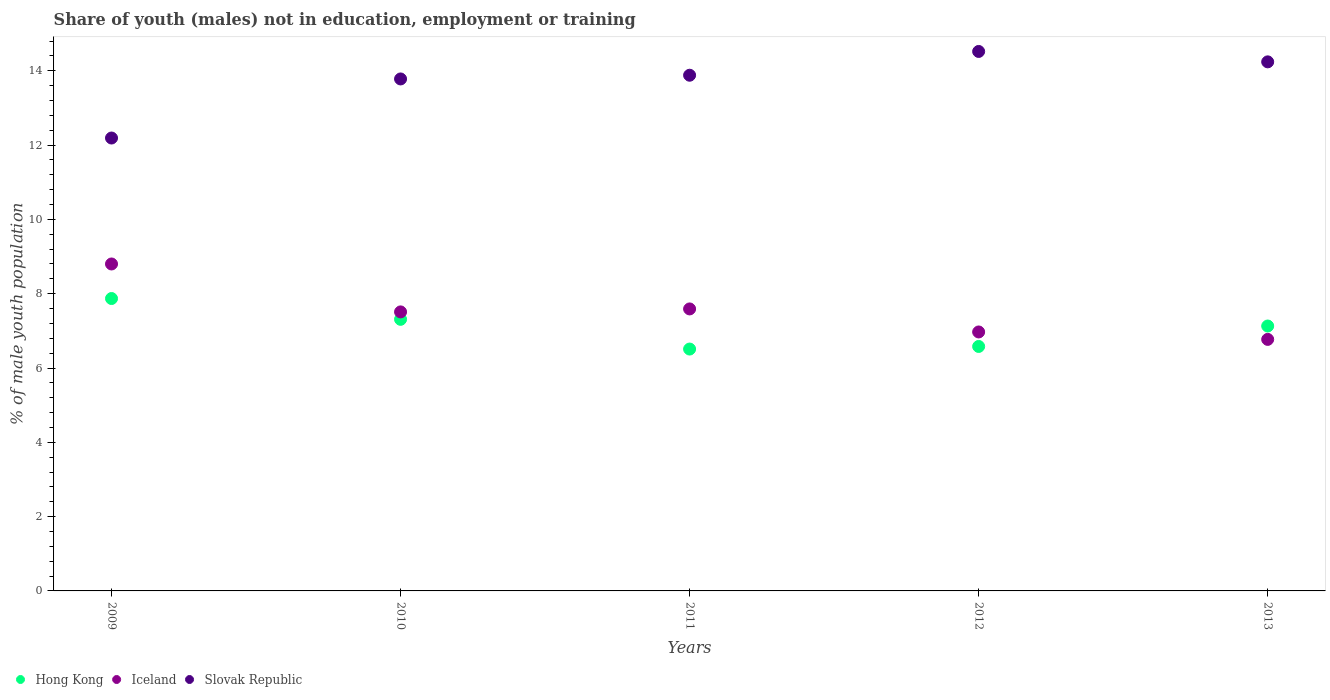How many different coloured dotlines are there?
Give a very brief answer. 3. Is the number of dotlines equal to the number of legend labels?
Ensure brevity in your answer.  Yes. What is the percentage of unemployed males population in in Hong Kong in 2013?
Keep it short and to the point. 7.13. Across all years, what is the maximum percentage of unemployed males population in in Slovak Republic?
Ensure brevity in your answer.  14.52. Across all years, what is the minimum percentage of unemployed males population in in Iceland?
Offer a terse response. 6.77. In which year was the percentage of unemployed males population in in Hong Kong maximum?
Keep it short and to the point. 2009. In which year was the percentage of unemployed males population in in Hong Kong minimum?
Provide a short and direct response. 2011. What is the total percentage of unemployed males population in in Iceland in the graph?
Offer a very short reply. 37.64. What is the difference between the percentage of unemployed males population in in Slovak Republic in 2011 and that in 2012?
Your answer should be compact. -0.64. What is the difference between the percentage of unemployed males population in in Slovak Republic in 2011 and the percentage of unemployed males population in in Iceland in 2013?
Make the answer very short. 7.11. What is the average percentage of unemployed males population in in Slovak Republic per year?
Ensure brevity in your answer.  13.72. In the year 2009, what is the difference between the percentage of unemployed males population in in Hong Kong and percentage of unemployed males population in in Iceland?
Keep it short and to the point. -0.93. In how many years, is the percentage of unemployed males population in in Iceland greater than 14.4 %?
Provide a short and direct response. 0. What is the ratio of the percentage of unemployed males population in in Slovak Republic in 2010 to that in 2011?
Provide a succinct answer. 0.99. Is the difference between the percentage of unemployed males population in in Hong Kong in 2011 and 2013 greater than the difference between the percentage of unemployed males population in in Iceland in 2011 and 2013?
Ensure brevity in your answer.  No. What is the difference between the highest and the second highest percentage of unemployed males population in in Slovak Republic?
Ensure brevity in your answer.  0.28. What is the difference between the highest and the lowest percentage of unemployed males population in in Slovak Republic?
Provide a short and direct response. 2.33. Does the percentage of unemployed males population in in Hong Kong monotonically increase over the years?
Offer a terse response. No. Is the percentage of unemployed males population in in Hong Kong strictly greater than the percentage of unemployed males population in in Iceland over the years?
Give a very brief answer. No. How many years are there in the graph?
Give a very brief answer. 5. What is the difference between two consecutive major ticks on the Y-axis?
Make the answer very short. 2. Are the values on the major ticks of Y-axis written in scientific E-notation?
Keep it short and to the point. No. Does the graph contain any zero values?
Your answer should be very brief. No. Does the graph contain grids?
Make the answer very short. No. Where does the legend appear in the graph?
Offer a very short reply. Bottom left. What is the title of the graph?
Ensure brevity in your answer.  Share of youth (males) not in education, employment or training. Does "Ireland" appear as one of the legend labels in the graph?
Your answer should be compact. No. What is the label or title of the Y-axis?
Provide a short and direct response. % of male youth population. What is the % of male youth population in Hong Kong in 2009?
Offer a very short reply. 7.87. What is the % of male youth population of Iceland in 2009?
Ensure brevity in your answer.  8.8. What is the % of male youth population of Slovak Republic in 2009?
Your answer should be compact. 12.19. What is the % of male youth population of Hong Kong in 2010?
Offer a very short reply. 7.31. What is the % of male youth population in Iceland in 2010?
Offer a terse response. 7.51. What is the % of male youth population of Slovak Republic in 2010?
Provide a short and direct response. 13.78. What is the % of male youth population in Hong Kong in 2011?
Provide a succinct answer. 6.51. What is the % of male youth population in Iceland in 2011?
Give a very brief answer. 7.59. What is the % of male youth population of Slovak Republic in 2011?
Make the answer very short. 13.88. What is the % of male youth population in Hong Kong in 2012?
Offer a terse response. 6.58. What is the % of male youth population of Iceland in 2012?
Your response must be concise. 6.97. What is the % of male youth population of Slovak Republic in 2012?
Your response must be concise. 14.52. What is the % of male youth population of Hong Kong in 2013?
Keep it short and to the point. 7.13. What is the % of male youth population in Iceland in 2013?
Your answer should be very brief. 6.77. What is the % of male youth population in Slovak Republic in 2013?
Your response must be concise. 14.24. Across all years, what is the maximum % of male youth population in Hong Kong?
Provide a succinct answer. 7.87. Across all years, what is the maximum % of male youth population of Iceland?
Provide a short and direct response. 8.8. Across all years, what is the maximum % of male youth population in Slovak Republic?
Make the answer very short. 14.52. Across all years, what is the minimum % of male youth population of Hong Kong?
Make the answer very short. 6.51. Across all years, what is the minimum % of male youth population in Iceland?
Keep it short and to the point. 6.77. Across all years, what is the minimum % of male youth population in Slovak Republic?
Make the answer very short. 12.19. What is the total % of male youth population of Hong Kong in the graph?
Keep it short and to the point. 35.4. What is the total % of male youth population in Iceland in the graph?
Provide a succinct answer. 37.64. What is the total % of male youth population in Slovak Republic in the graph?
Provide a succinct answer. 68.61. What is the difference between the % of male youth population of Hong Kong in 2009 and that in 2010?
Offer a very short reply. 0.56. What is the difference between the % of male youth population in Iceland in 2009 and that in 2010?
Offer a terse response. 1.29. What is the difference between the % of male youth population in Slovak Republic in 2009 and that in 2010?
Provide a succinct answer. -1.59. What is the difference between the % of male youth population of Hong Kong in 2009 and that in 2011?
Keep it short and to the point. 1.36. What is the difference between the % of male youth population in Iceland in 2009 and that in 2011?
Keep it short and to the point. 1.21. What is the difference between the % of male youth population in Slovak Republic in 2009 and that in 2011?
Your answer should be compact. -1.69. What is the difference between the % of male youth population of Hong Kong in 2009 and that in 2012?
Give a very brief answer. 1.29. What is the difference between the % of male youth population of Iceland in 2009 and that in 2012?
Give a very brief answer. 1.83. What is the difference between the % of male youth population of Slovak Republic in 2009 and that in 2012?
Provide a short and direct response. -2.33. What is the difference between the % of male youth population in Hong Kong in 2009 and that in 2013?
Give a very brief answer. 0.74. What is the difference between the % of male youth population of Iceland in 2009 and that in 2013?
Offer a terse response. 2.03. What is the difference between the % of male youth population in Slovak Republic in 2009 and that in 2013?
Offer a terse response. -2.05. What is the difference between the % of male youth population of Iceland in 2010 and that in 2011?
Ensure brevity in your answer.  -0.08. What is the difference between the % of male youth population of Hong Kong in 2010 and that in 2012?
Offer a very short reply. 0.73. What is the difference between the % of male youth population in Iceland in 2010 and that in 2012?
Your answer should be very brief. 0.54. What is the difference between the % of male youth population of Slovak Republic in 2010 and that in 2012?
Provide a short and direct response. -0.74. What is the difference between the % of male youth population in Hong Kong in 2010 and that in 2013?
Keep it short and to the point. 0.18. What is the difference between the % of male youth population in Iceland in 2010 and that in 2013?
Offer a terse response. 0.74. What is the difference between the % of male youth population in Slovak Republic in 2010 and that in 2013?
Make the answer very short. -0.46. What is the difference between the % of male youth population of Hong Kong in 2011 and that in 2012?
Make the answer very short. -0.07. What is the difference between the % of male youth population of Iceland in 2011 and that in 2012?
Give a very brief answer. 0.62. What is the difference between the % of male youth population in Slovak Republic in 2011 and that in 2012?
Offer a terse response. -0.64. What is the difference between the % of male youth population of Hong Kong in 2011 and that in 2013?
Keep it short and to the point. -0.62. What is the difference between the % of male youth population of Iceland in 2011 and that in 2013?
Make the answer very short. 0.82. What is the difference between the % of male youth population in Slovak Republic in 2011 and that in 2013?
Offer a very short reply. -0.36. What is the difference between the % of male youth population in Hong Kong in 2012 and that in 2013?
Your answer should be very brief. -0.55. What is the difference between the % of male youth population in Iceland in 2012 and that in 2013?
Provide a succinct answer. 0.2. What is the difference between the % of male youth population in Slovak Republic in 2012 and that in 2013?
Keep it short and to the point. 0.28. What is the difference between the % of male youth population of Hong Kong in 2009 and the % of male youth population of Iceland in 2010?
Your answer should be very brief. 0.36. What is the difference between the % of male youth population of Hong Kong in 2009 and the % of male youth population of Slovak Republic in 2010?
Your response must be concise. -5.91. What is the difference between the % of male youth population in Iceland in 2009 and the % of male youth population in Slovak Republic in 2010?
Keep it short and to the point. -4.98. What is the difference between the % of male youth population of Hong Kong in 2009 and the % of male youth population of Iceland in 2011?
Give a very brief answer. 0.28. What is the difference between the % of male youth population of Hong Kong in 2009 and the % of male youth population of Slovak Republic in 2011?
Your answer should be very brief. -6.01. What is the difference between the % of male youth population in Iceland in 2009 and the % of male youth population in Slovak Republic in 2011?
Your response must be concise. -5.08. What is the difference between the % of male youth population in Hong Kong in 2009 and the % of male youth population in Slovak Republic in 2012?
Provide a succinct answer. -6.65. What is the difference between the % of male youth population of Iceland in 2009 and the % of male youth population of Slovak Republic in 2012?
Offer a very short reply. -5.72. What is the difference between the % of male youth population in Hong Kong in 2009 and the % of male youth population in Iceland in 2013?
Offer a very short reply. 1.1. What is the difference between the % of male youth population in Hong Kong in 2009 and the % of male youth population in Slovak Republic in 2013?
Keep it short and to the point. -6.37. What is the difference between the % of male youth population of Iceland in 2009 and the % of male youth population of Slovak Republic in 2013?
Your response must be concise. -5.44. What is the difference between the % of male youth population of Hong Kong in 2010 and the % of male youth population of Iceland in 2011?
Your response must be concise. -0.28. What is the difference between the % of male youth population in Hong Kong in 2010 and the % of male youth population in Slovak Republic in 2011?
Give a very brief answer. -6.57. What is the difference between the % of male youth population of Iceland in 2010 and the % of male youth population of Slovak Republic in 2011?
Provide a short and direct response. -6.37. What is the difference between the % of male youth population of Hong Kong in 2010 and the % of male youth population of Iceland in 2012?
Your response must be concise. 0.34. What is the difference between the % of male youth population in Hong Kong in 2010 and the % of male youth population in Slovak Republic in 2012?
Provide a succinct answer. -7.21. What is the difference between the % of male youth population in Iceland in 2010 and the % of male youth population in Slovak Republic in 2012?
Offer a very short reply. -7.01. What is the difference between the % of male youth population of Hong Kong in 2010 and the % of male youth population of Iceland in 2013?
Your answer should be very brief. 0.54. What is the difference between the % of male youth population of Hong Kong in 2010 and the % of male youth population of Slovak Republic in 2013?
Your answer should be compact. -6.93. What is the difference between the % of male youth population of Iceland in 2010 and the % of male youth population of Slovak Republic in 2013?
Your answer should be compact. -6.73. What is the difference between the % of male youth population in Hong Kong in 2011 and the % of male youth population in Iceland in 2012?
Offer a very short reply. -0.46. What is the difference between the % of male youth population of Hong Kong in 2011 and the % of male youth population of Slovak Republic in 2012?
Give a very brief answer. -8.01. What is the difference between the % of male youth population of Iceland in 2011 and the % of male youth population of Slovak Republic in 2012?
Give a very brief answer. -6.93. What is the difference between the % of male youth population in Hong Kong in 2011 and the % of male youth population in Iceland in 2013?
Your answer should be very brief. -0.26. What is the difference between the % of male youth population of Hong Kong in 2011 and the % of male youth population of Slovak Republic in 2013?
Your answer should be compact. -7.73. What is the difference between the % of male youth population in Iceland in 2011 and the % of male youth population in Slovak Republic in 2013?
Keep it short and to the point. -6.65. What is the difference between the % of male youth population in Hong Kong in 2012 and the % of male youth population in Iceland in 2013?
Make the answer very short. -0.19. What is the difference between the % of male youth population of Hong Kong in 2012 and the % of male youth population of Slovak Republic in 2013?
Provide a short and direct response. -7.66. What is the difference between the % of male youth population in Iceland in 2012 and the % of male youth population in Slovak Republic in 2013?
Make the answer very short. -7.27. What is the average % of male youth population of Hong Kong per year?
Offer a terse response. 7.08. What is the average % of male youth population in Iceland per year?
Provide a succinct answer. 7.53. What is the average % of male youth population in Slovak Republic per year?
Your answer should be very brief. 13.72. In the year 2009, what is the difference between the % of male youth population of Hong Kong and % of male youth population of Iceland?
Offer a very short reply. -0.93. In the year 2009, what is the difference between the % of male youth population of Hong Kong and % of male youth population of Slovak Republic?
Provide a short and direct response. -4.32. In the year 2009, what is the difference between the % of male youth population in Iceland and % of male youth population in Slovak Republic?
Offer a terse response. -3.39. In the year 2010, what is the difference between the % of male youth population of Hong Kong and % of male youth population of Iceland?
Your response must be concise. -0.2. In the year 2010, what is the difference between the % of male youth population of Hong Kong and % of male youth population of Slovak Republic?
Give a very brief answer. -6.47. In the year 2010, what is the difference between the % of male youth population in Iceland and % of male youth population in Slovak Republic?
Your response must be concise. -6.27. In the year 2011, what is the difference between the % of male youth population of Hong Kong and % of male youth population of Iceland?
Your answer should be compact. -1.08. In the year 2011, what is the difference between the % of male youth population in Hong Kong and % of male youth population in Slovak Republic?
Your response must be concise. -7.37. In the year 2011, what is the difference between the % of male youth population in Iceland and % of male youth population in Slovak Republic?
Your answer should be very brief. -6.29. In the year 2012, what is the difference between the % of male youth population of Hong Kong and % of male youth population of Iceland?
Make the answer very short. -0.39. In the year 2012, what is the difference between the % of male youth population of Hong Kong and % of male youth population of Slovak Republic?
Offer a very short reply. -7.94. In the year 2012, what is the difference between the % of male youth population in Iceland and % of male youth population in Slovak Republic?
Your answer should be compact. -7.55. In the year 2013, what is the difference between the % of male youth population in Hong Kong and % of male youth population in Iceland?
Offer a very short reply. 0.36. In the year 2013, what is the difference between the % of male youth population in Hong Kong and % of male youth population in Slovak Republic?
Give a very brief answer. -7.11. In the year 2013, what is the difference between the % of male youth population of Iceland and % of male youth population of Slovak Republic?
Make the answer very short. -7.47. What is the ratio of the % of male youth population in Hong Kong in 2009 to that in 2010?
Ensure brevity in your answer.  1.08. What is the ratio of the % of male youth population in Iceland in 2009 to that in 2010?
Your response must be concise. 1.17. What is the ratio of the % of male youth population in Slovak Republic in 2009 to that in 2010?
Offer a terse response. 0.88. What is the ratio of the % of male youth population in Hong Kong in 2009 to that in 2011?
Your answer should be compact. 1.21. What is the ratio of the % of male youth population of Iceland in 2009 to that in 2011?
Keep it short and to the point. 1.16. What is the ratio of the % of male youth population of Slovak Republic in 2009 to that in 2011?
Make the answer very short. 0.88. What is the ratio of the % of male youth population of Hong Kong in 2009 to that in 2012?
Provide a succinct answer. 1.2. What is the ratio of the % of male youth population of Iceland in 2009 to that in 2012?
Your answer should be compact. 1.26. What is the ratio of the % of male youth population in Slovak Republic in 2009 to that in 2012?
Offer a terse response. 0.84. What is the ratio of the % of male youth population of Hong Kong in 2009 to that in 2013?
Ensure brevity in your answer.  1.1. What is the ratio of the % of male youth population of Iceland in 2009 to that in 2013?
Make the answer very short. 1.3. What is the ratio of the % of male youth population in Slovak Republic in 2009 to that in 2013?
Give a very brief answer. 0.86. What is the ratio of the % of male youth population in Hong Kong in 2010 to that in 2011?
Make the answer very short. 1.12. What is the ratio of the % of male youth population of Hong Kong in 2010 to that in 2012?
Ensure brevity in your answer.  1.11. What is the ratio of the % of male youth population of Iceland in 2010 to that in 2012?
Offer a very short reply. 1.08. What is the ratio of the % of male youth population of Slovak Republic in 2010 to that in 2012?
Make the answer very short. 0.95. What is the ratio of the % of male youth population in Hong Kong in 2010 to that in 2013?
Provide a short and direct response. 1.03. What is the ratio of the % of male youth population of Iceland in 2010 to that in 2013?
Offer a terse response. 1.11. What is the ratio of the % of male youth population of Slovak Republic in 2010 to that in 2013?
Give a very brief answer. 0.97. What is the ratio of the % of male youth population in Hong Kong in 2011 to that in 2012?
Offer a terse response. 0.99. What is the ratio of the % of male youth population in Iceland in 2011 to that in 2012?
Make the answer very short. 1.09. What is the ratio of the % of male youth population of Slovak Republic in 2011 to that in 2012?
Provide a short and direct response. 0.96. What is the ratio of the % of male youth population in Hong Kong in 2011 to that in 2013?
Give a very brief answer. 0.91. What is the ratio of the % of male youth population of Iceland in 2011 to that in 2013?
Your answer should be compact. 1.12. What is the ratio of the % of male youth population of Slovak Republic in 2011 to that in 2013?
Give a very brief answer. 0.97. What is the ratio of the % of male youth population in Hong Kong in 2012 to that in 2013?
Ensure brevity in your answer.  0.92. What is the ratio of the % of male youth population in Iceland in 2012 to that in 2013?
Keep it short and to the point. 1.03. What is the ratio of the % of male youth population in Slovak Republic in 2012 to that in 2013?
Your response must be concise. 1.02. What is the difference between the highest and the second highest % of male youth population in Hong Kong?
Give a very brief answer. 0.56. What is the difference between the highest and the second highest % of male youth population of Iceland?
Ensure brevity in your answer.  1.21. What is the difference between the highest and the second highest % of male youth population of Slovak Republic?
Your response must be concise. 0.28. What is the difference between the highest and the lowest % of male youth population in Hong Kong?
Your answer should be very brief. 1.36. What is the difference between the highest and the lowest % of male youth population of Iceland?
Your answer should be very brief. 2.03. What is the difference between the highest and the lowest % of male youth population of Slovak Republic?
Your answer should be compact. 2.33. 